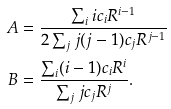<formula> <loc_0><loc_0><loc_500><loc_500>A & = \frac { \sum _ { i } i c _ { i } R ^ { i - 1 } } { 2 \sum _ { j } j ( j - 1 ) c _ { j } R ^ { j - 1 } } \\ B & = \frac { \sum _ { i } ( i - 1 ) c _ { i } R ^ { i } } { \sum _ { j } j c _ { j } R ^ { j } } .</formula> 